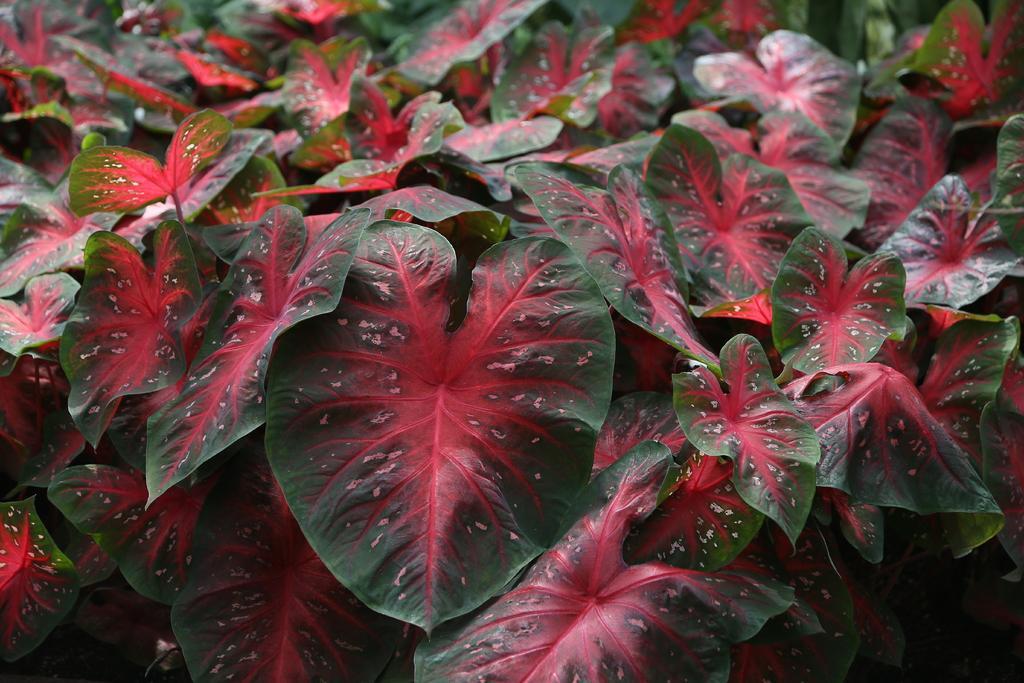Can you describe this image briefly? In this image we can see leaves. 